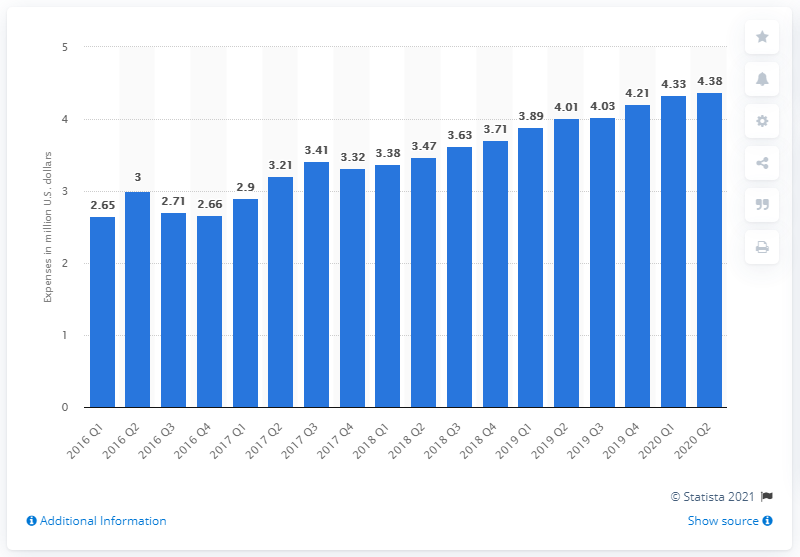Identify some key points in this picture. Amazon spent 4.38 billion dollars promoting its interests in the United States in the second quarter of 2020. 